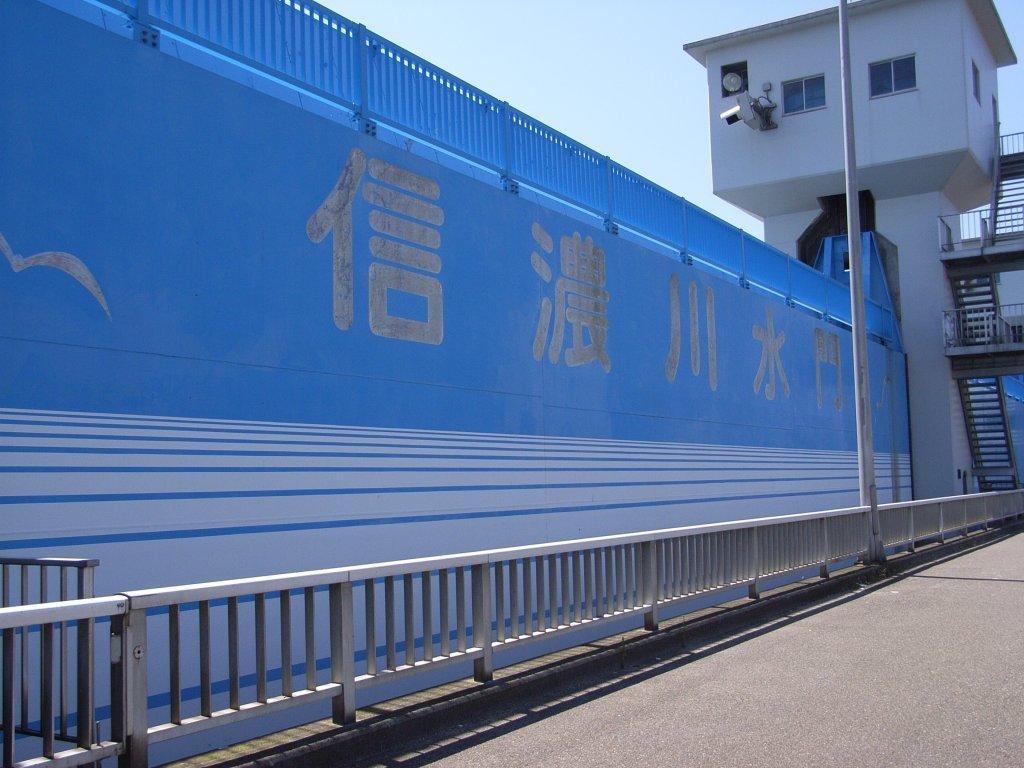Please provide a concise description of this image. In this image in the front there is a railing which is white in colour and there is a pole. In the background there is a wall and on the wall there are some text written and on the top of the wall there is a railing which is blue in colour. In the background there is a tower and there are staircases 